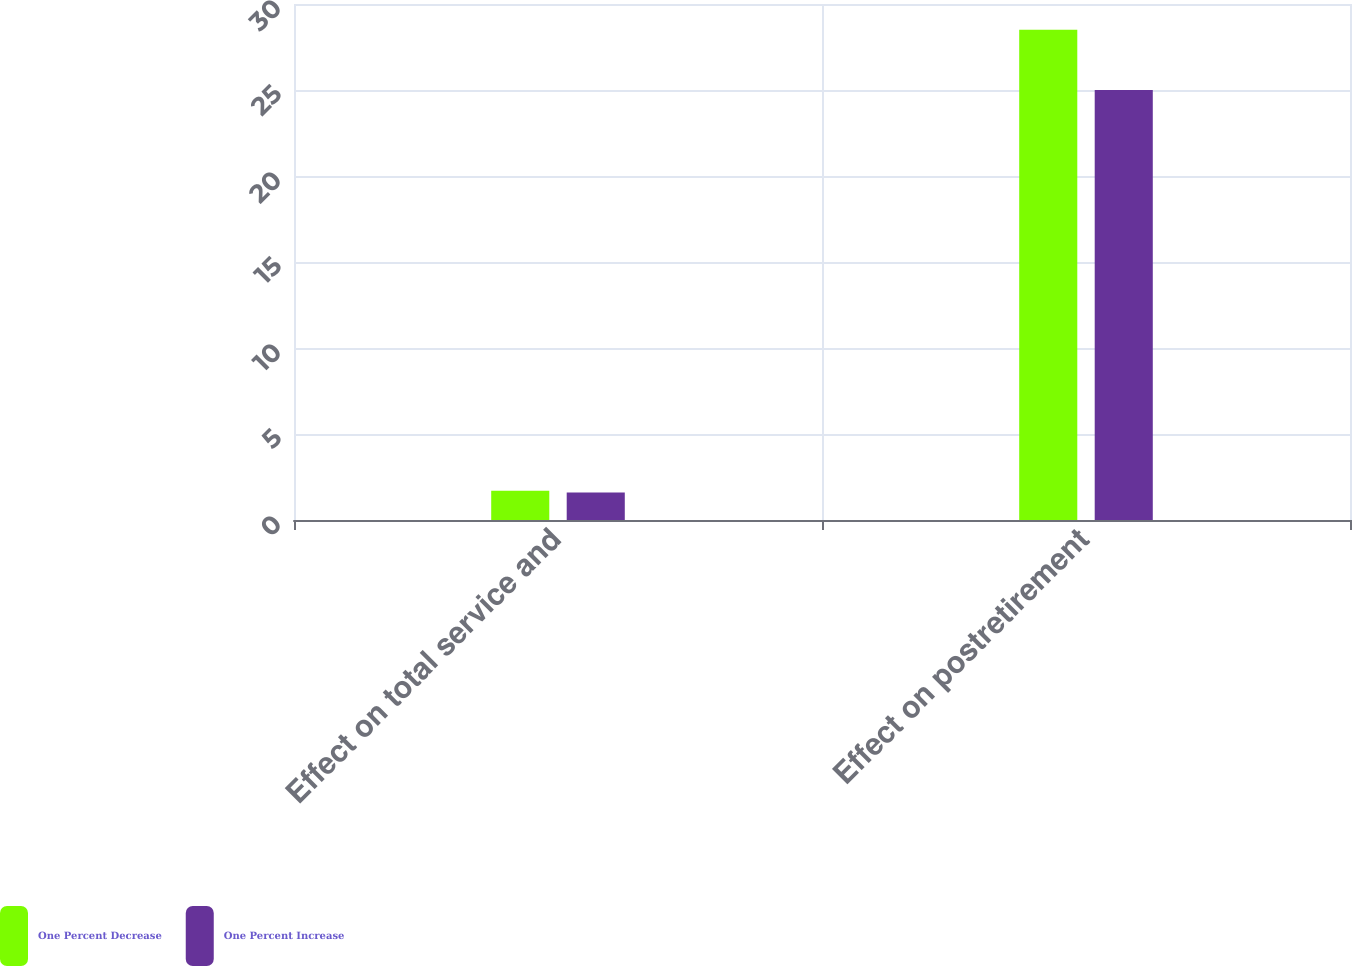Convert chart to OTSL. <chart><loc_0><loc_0><loc_500><loc_500><stacked_bar_chart><ecel><fcel>Effect on total service and<fcel>Effect on postretirement<nl><fcel>One Percent Decrease<fcel>1.7<fcel>28.5<nl><fcel>One Percent Increase<fcel>1.6<fcel>25<nl></chart> 